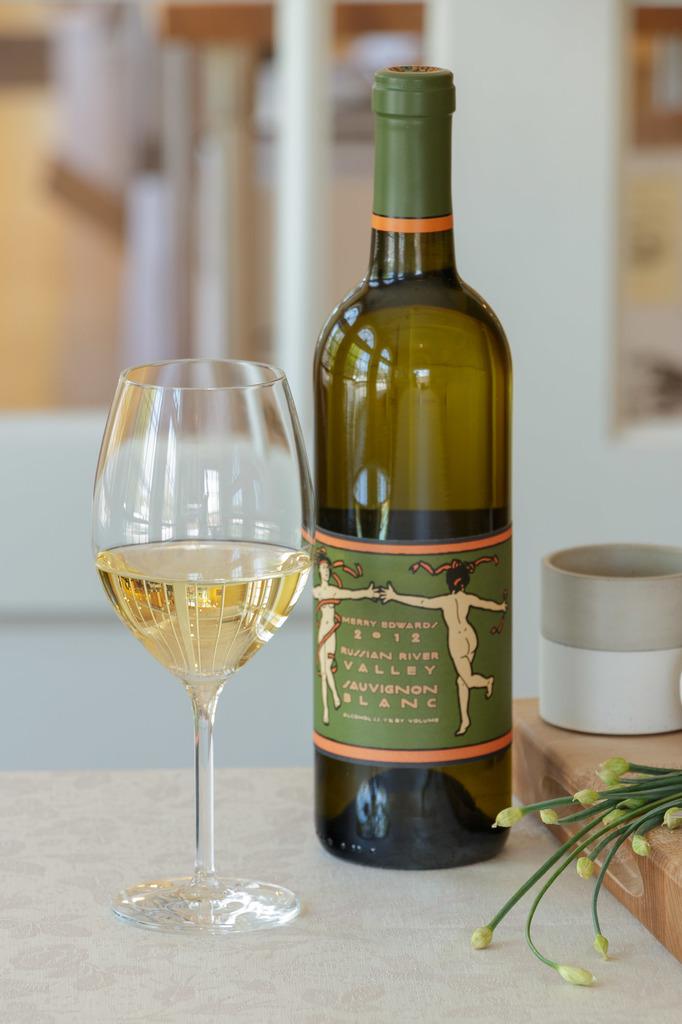What kind of wine is this?
Provide a succinct answer. Sauvignon blanc. What year was this made?
Keep it short and to the point. 2012. 